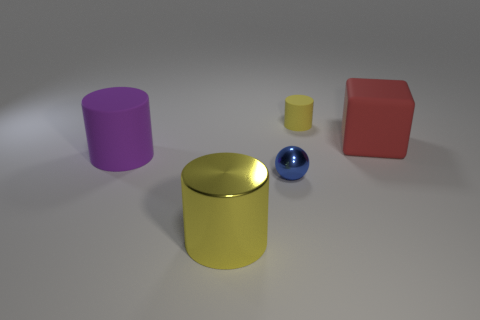Subtract 1 cylinders. How many cylinders are left? 2 Add 1 brown things. How many objects exist? 6 Subtract all cubes. How many objects are left? 4 Add 2 large matte objects. How many large matte objects exist? 4 Subtract 0 gray cylinders. How many objects are left? 5 Subtract all large blue rubber cylinders. Subtract all big purple things. How many objects are left? 4 Add 3 blue balls. How many blue balls are left? 4 